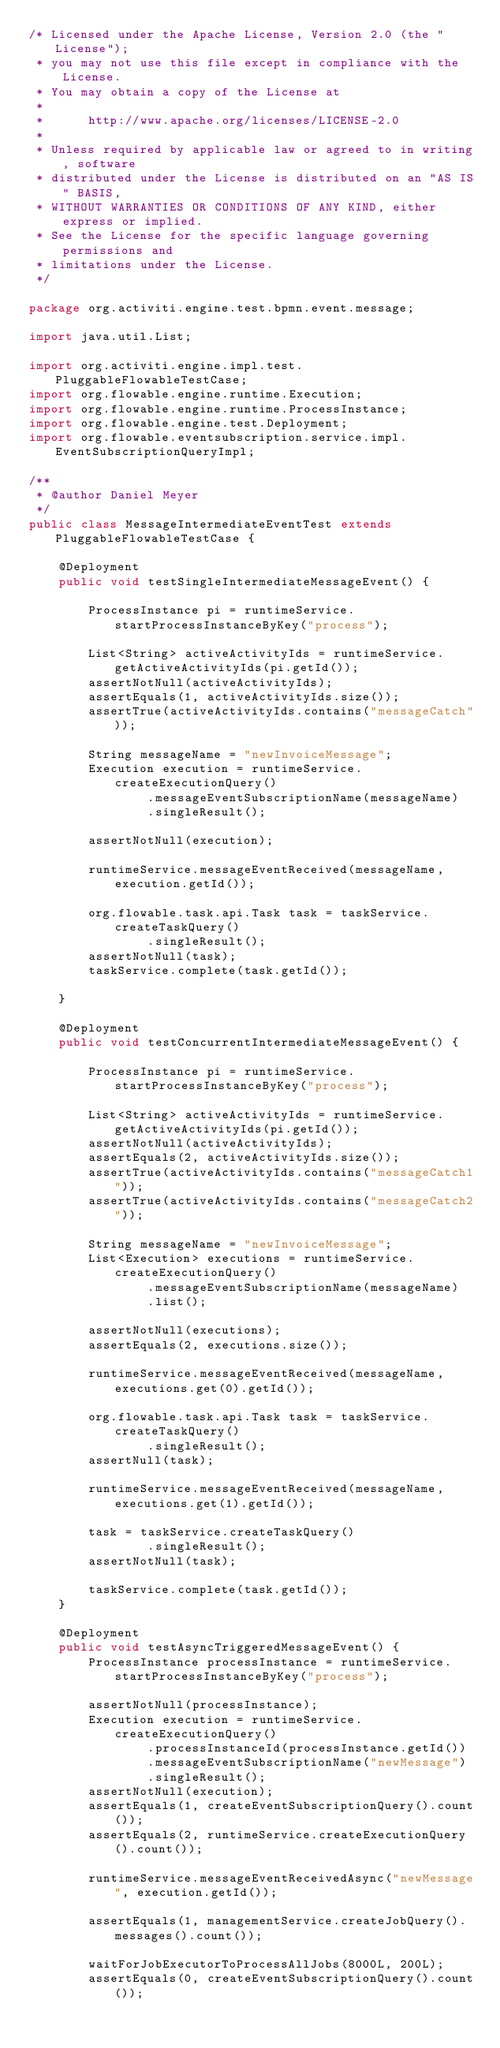Convert code to text. <code><loc_0><loc_0><loc_500><loc_500><_Java_>/* Licensed under the Apache License, Version 2.0 (the "License");
 * you may not use this file except in compliance with the License.
 * You may obtain a copy of the License at
 * 
 *      http://www.apache.org/licenses/LICENSE-2.0
 * 
 * Unless required by applicable law or agreed to in writing, software
 * distributed under the License is distributed on an "AS IS" BASIS,
 * WITHOUT WARRANTIES OR CONDITIONS OF ANY KIND, either express or implied.
 * See the License for the specific language governing permissions and
 * limitations under the License.
 */

package org.activiti.engine.test.bpmn.event.message;

import java.util.List;

import org.activiti.engine.impl.test.PluggableFlowableTestCase;
import org.flowable.engine.runtime.Execution;
import org.flowable.engine.runtime.ProcessInstance;
import org.flowable.engine.test.Deployment;
import org.flowable.eventsubscription.service.impl.EventSubscriptionQueryImpl;

/**
 * @author Daniel Meyer
 */
public class MessageIntermediateEventTest extends PluggableFlowableTestCase {

    @Deployment
    public void testSingleIntermediateMessageEvent() {

        ProcessInstance pi = runtimeService.startProcessInstanceByKey("process");

        List<String> activeActivityIds = runtimeService.getActiveActivityIds(pi.getId());
        assertNotNull(activeActivityIds);
        assertEquals(1, activeActivityIds.size());
        assertTrue(activeActivityIds.contains("messageCatch"));

        String messageName = "newInvoiceMessage";
        Execution execution = runtimeService.createExecutionQuery()
                .messageEventSubscriptionName(messageName)
                .singleResult();

        assertNotNull(execution);

        runtimeService.messageEventReceived(messageName, execution.getId());

        org.flowable.task.api.Task task = taskService.createTaskQuery()
                .singleResult();
        assertNotNull(task);
        taskService.complete(task.getId());

    }

    @Deployment
    public void testConcurrentIntermediateMessageEvent() {

        ProcessInstance pi = runtimeService.startProcessInstanceByKey("process");

        List<String> activeActivityIds = runtimeService.getActiveActivityIds(pi.getId());
        assertNotNull(activeActivityIds);
        assertEquals(2, activeActivityIds.size());
        assertTrue(activeActivityIds.contains("messageCatch1"));
        assertTrue(activeActivityIds.contains("messageCatch2"));

        String messageName = "newInvoiceMessage";
        List<Execution> executions = runtimeService.createExecutionQuery()
                .messageEventSubscriptionName(messageName)
                .list();

        assertNotNull(executions);
        assertEquals(2, executions.size());

        runtimeService.messageEventReceived(messageName, executions.get(0).getId());

        org.flowable.task.api.Task task = taskService.createTaskQuery()
                .singleResult();
        assertNull(task);

        runtimeService.messageEventReceived(messageName, executions.get(1).getId());

        task = taskService.createTaskQuery()
                .singleResult();
        assertNotNull(task);

        taskService.complete(task.getId());
    }

    @Deployment
    public void testAsyncTriggeredMessageEvent() {
        ProcessInstance processInstance = runtimeService.startProcessInstanceByKey("process");

        assertNotNull(processInstance);
        Execution execution = runtimeService.createExecutionQuery()
                .processInstanceId(processInstance.getId())
                .messageEventSubscriptionName("newMessage")
                .singleResult();
        assertNotNull(execution);
        assertEquals(1, createEventSubscriptionQuery().count());
        assertEquals(2, runtimeService.createExecutionQuery().count());

        runtimeService.messageEventReceivedAsync("newMessage", execution.getId());

        assertEquals(1, managementService.createJobQuery().messages().count());

        waitForJobExecutorToProcessAllJobs(8000L, 200L);
        assertEquals(0, createEventSubscriptionQuery().count());</code> 